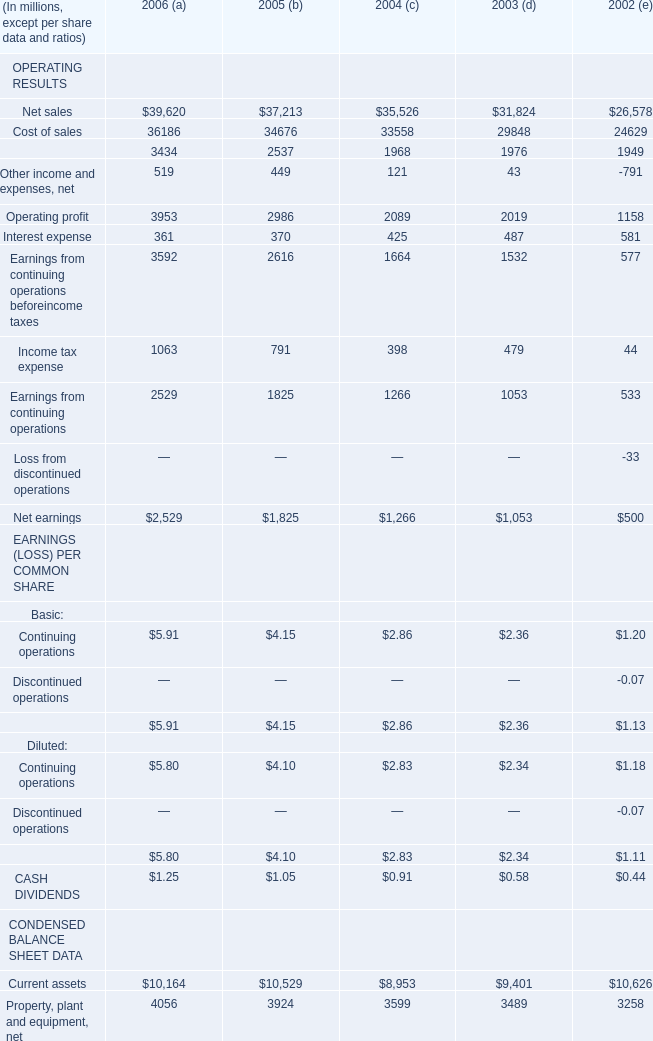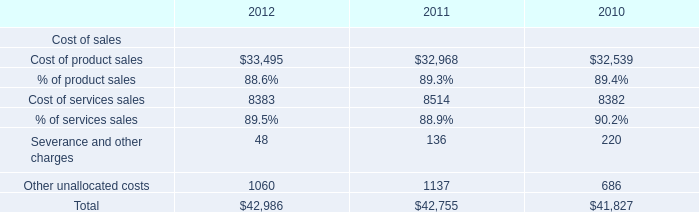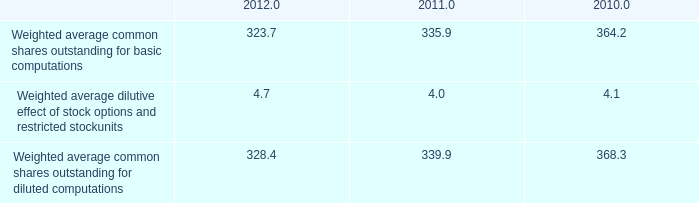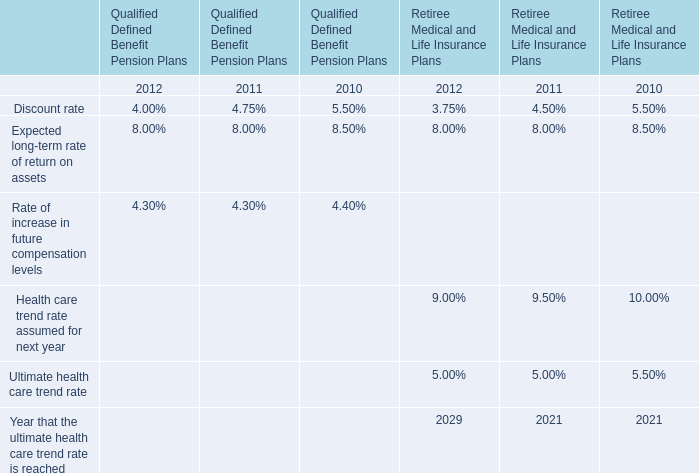what is the percentage change in the weighted average common shares outstanding for basic computations from 2011 to 2012? 
Computations: ((323.7 - 335.9) / 335.9)
Answer: -0.03632. 